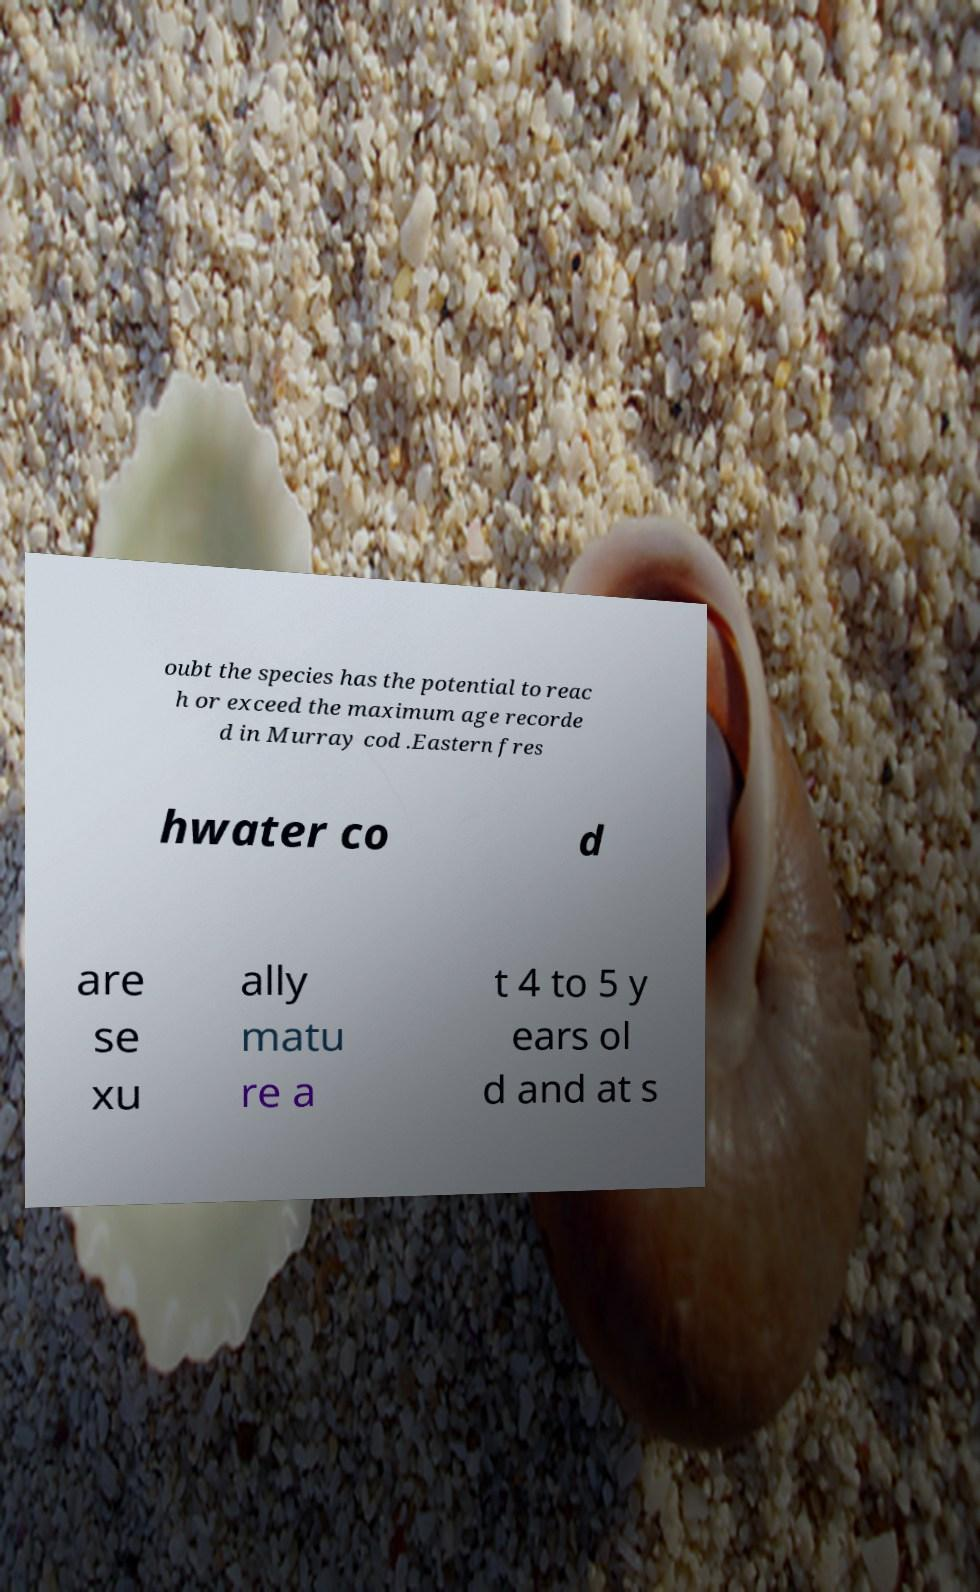Please identify and transcribe the text found in this image. oubt the species has the potential to reac h or exceed the maximum age recorde d in Murray cod .Eastern fres hwater co d are se xu ally matu re a t 4 to 5 y ears ol d and at s 